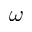Convert formula to latex. <formula><loc_0><loc_0><loc_500><loc_500>\omega</formula> 